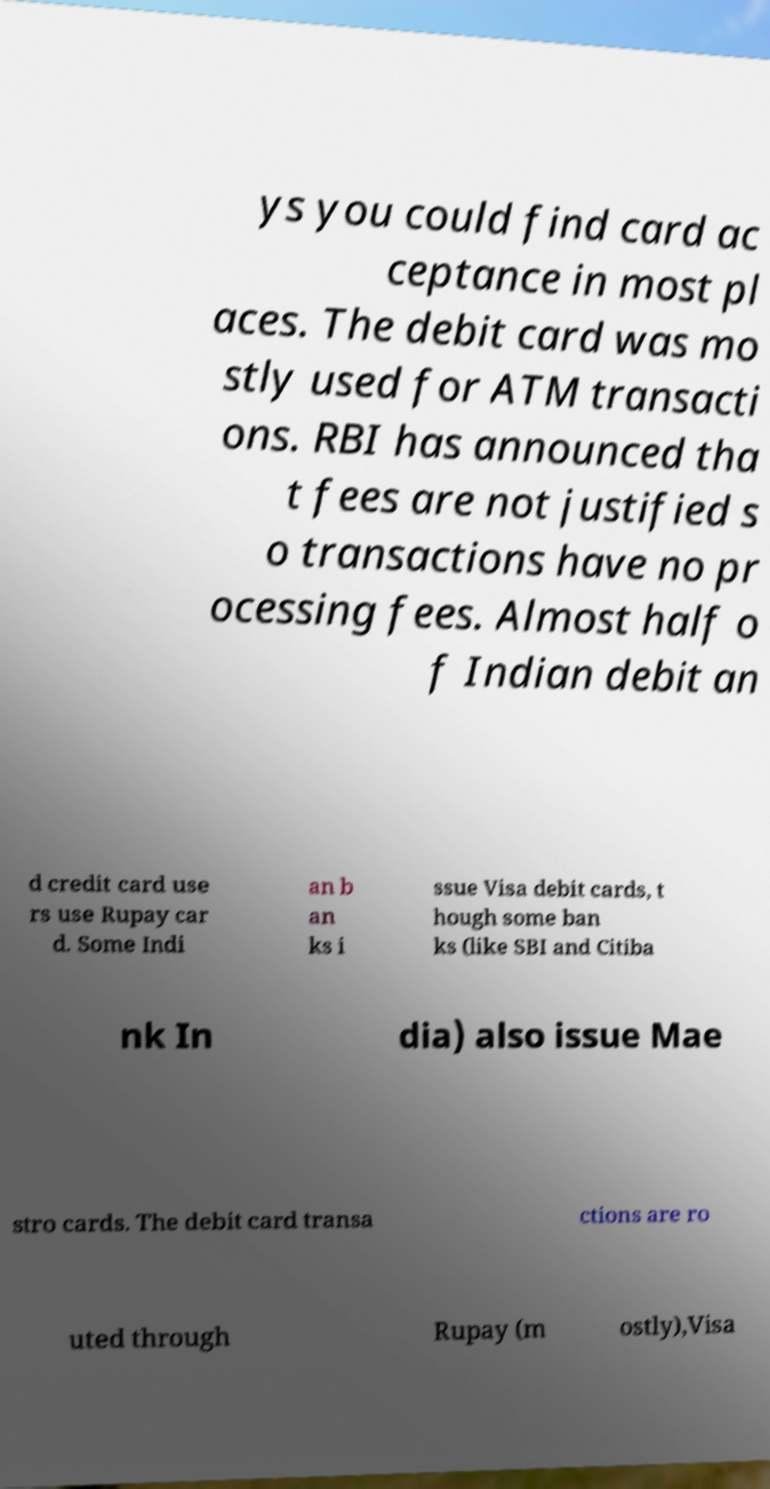For documentation purposes, I need the text within this image transcribed. Could you provide that? ys you could find card ac ceptance in most pl aces. The debit card was mo stly used for ATM transacti ons. RBI has announced tha t fees are not justified s o transactions have no pr ocessing fees. Almost half o f Indian debit an d credit card use rs use Rupay car d. Some Indi an b an ks i ssue Visa debit cards, t hough some ban ks (like SBI and Citiba nk In dia) also issue Mae stro cards. The debit card transa ctions are ro uted through Rupay (m ostly),Visa 